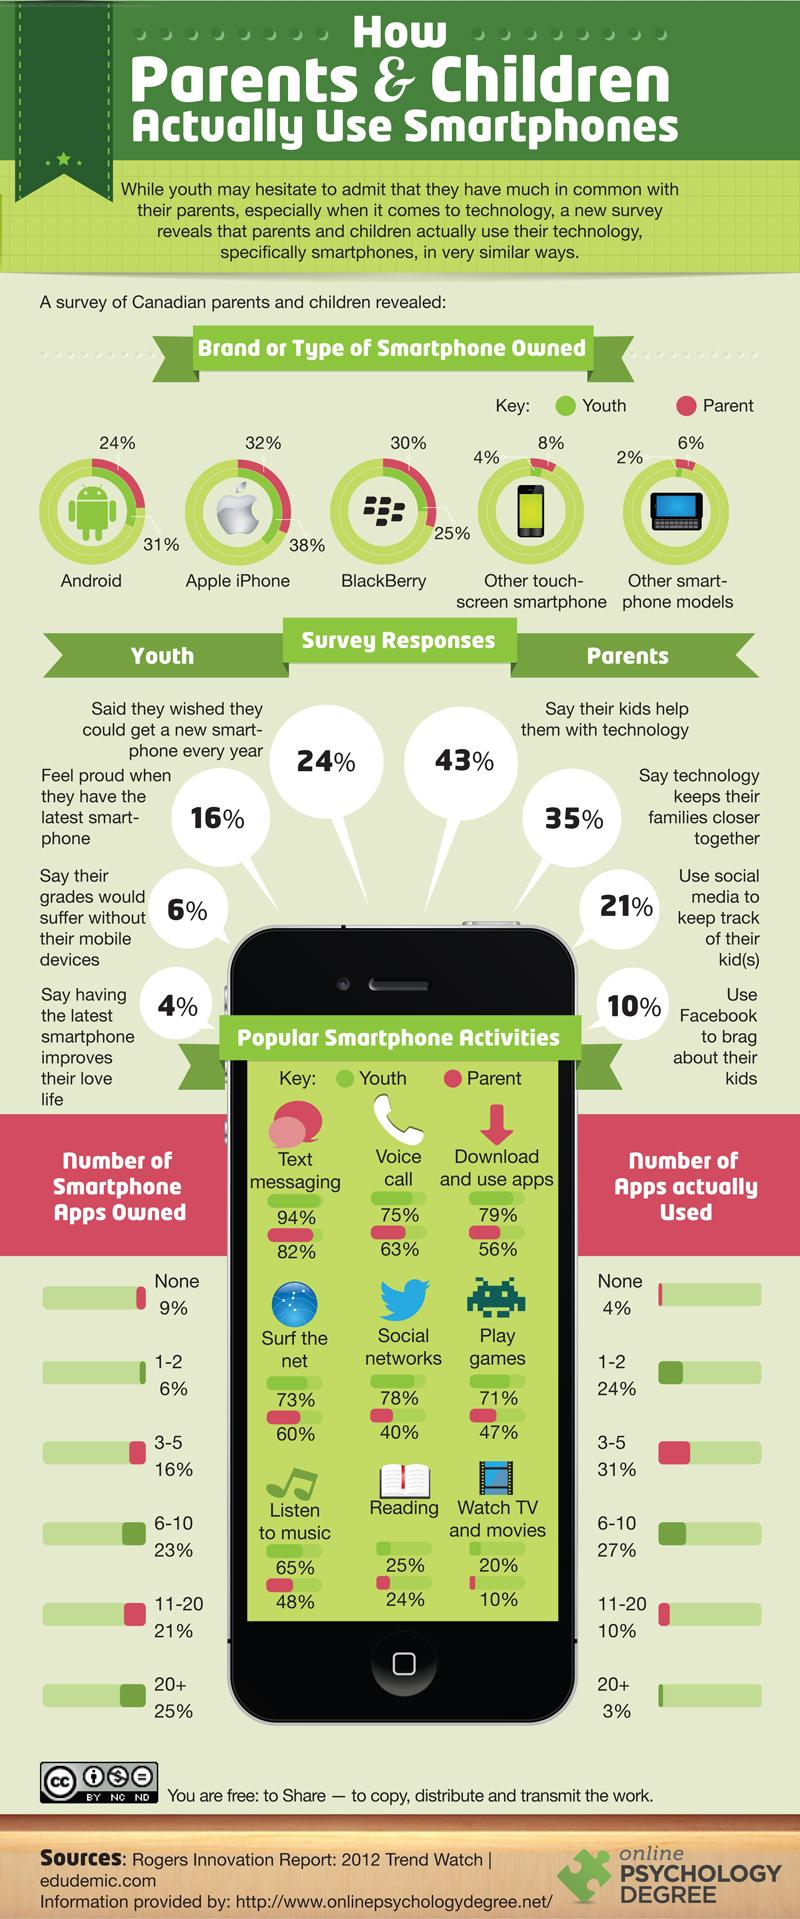Mention a couple of crucial points in this snapshot. According to a survey, only 9% of Canadian parents do not have any smartphone apps. According to a survey of Canadian parents, 48% reported using smartphones to listen to music. According to the survey, 38% of Canadian youth owned an Apple iPhone in 2020. According to a survey, 63% of Canadian parents use voice calling using smartphones. According to a survey, 47% of Canadian parents play games using smartphones. 